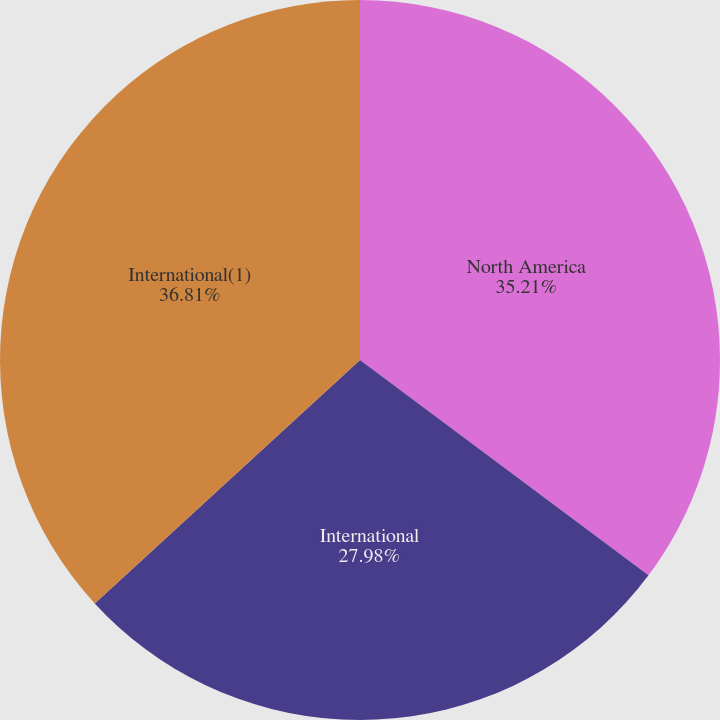Convert chart to OTSL. <chart><loc_0><loc_0><loc_500><loc_500><pie_chart><fcel>North America<fcel>International<fcel>International(1)<nl><fcel>35.21%<fcel>27.98%<fcel>36.82%<nl></chart> 